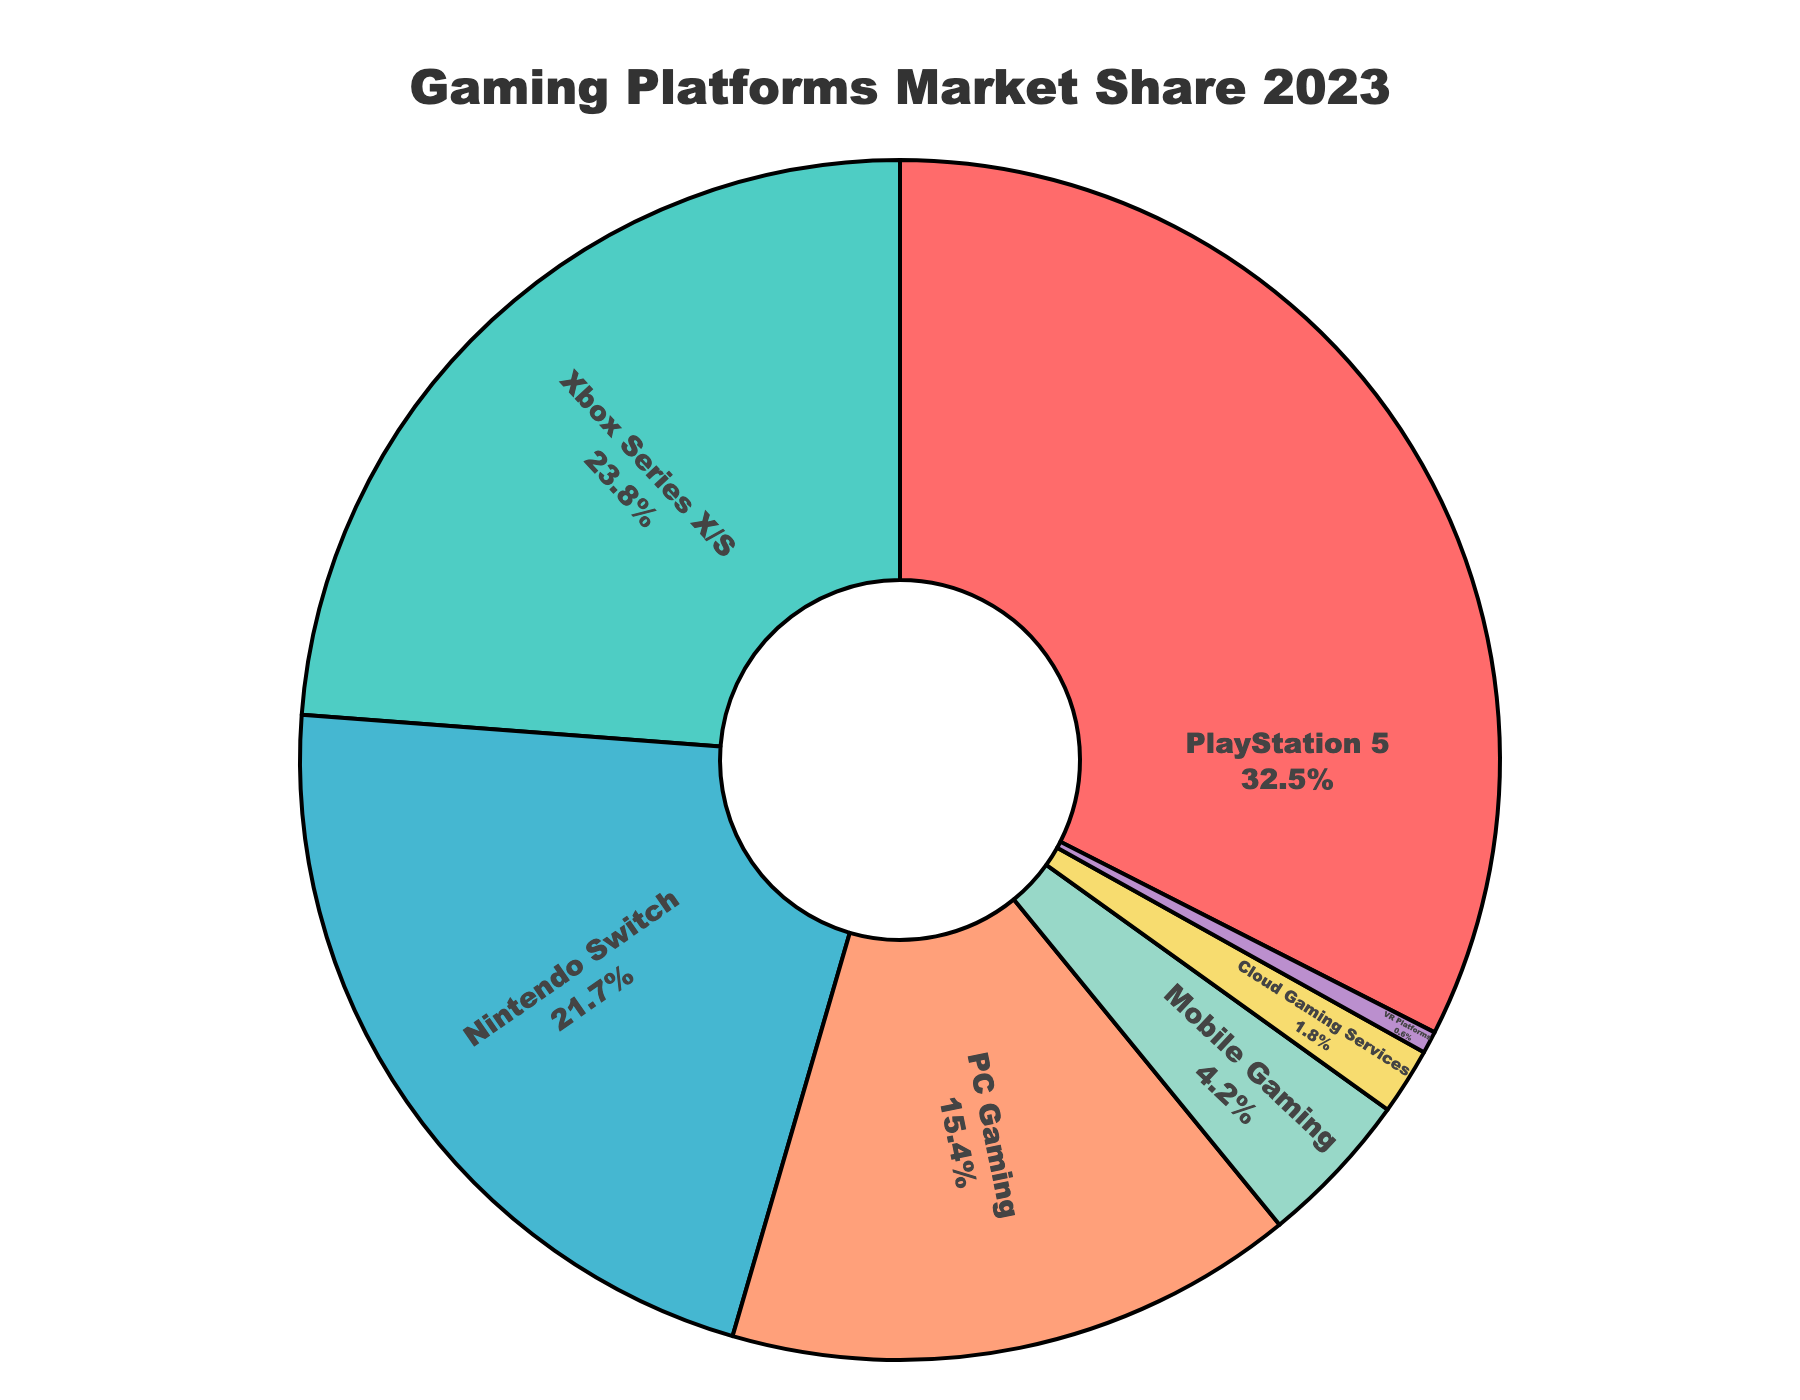What is the platform with the highest market share? The chart shows the market share percentages of various gaming platforms. The platform with the largest market share is the one with the highest value. Based on the data, PlayStation 5 has the highest market share of 32.5%.
Answer: PlayStation 5 Which platform has a smaller market share: Mobile Gaming or Cloud Gaming Services? To determine which platform has a smaller market share, compare the percentages for Mobile Gaming and Cloud Gaming Services. Mobile Gaming has a market share of 4.2%, and Cloud Gaming Services has 1.8%. Since 1.8% is less than 4.2%, Cloud Gaming Services has a smaller market share.
Answer: Cloud Gaming Services How much larger is the market share of Xbox Series X/S compared to VR Platforms? To find how much larger Xbox Series X/S's market share is compared to VR Platforms, subtract the market share of VR Platforms from that of Xbox Series X/S. Xbox Series X/S has 23.8% and VR Platforms have 0.6%. So, 23.8% - 0.6% = 23.2%.
Answer: 23.2% What is the combined market share of PC Gaming and Mobile Gaming? To find the combined market share, add the market shares of PC Gaming and Mobile Gaming. PC Gaming has 15.4% and Mobile Gaming has 4.2%. So, 15.4% + 4.2% = 19.6%.
Answer: 19.6% Between PlayStation 5 and Nintendo Switch, which has a greater market share and by how much? Compare the market shares of PlayStation 5 and Nintendo Switch. PlayStation 5 has 32.5% and Nintendo Switch has 21.7%. Subtract Nintendo Switch's share from PlayStation 5's: 32.5% - 21.7% = 10.8%.
Answer: PlayStation 5, 10.8% Which platforms have less than 10% market share? The chart shows the market share percentages of various platforms. Identify those with values less than 10%. The platforms fitting this criterion are Mobile Gaming at 4.2%, Cloud Gaming Services at 1.8%, and VR Platforms at 0.6%.
Answer: Mobile Gaming, Cloud Gaming Services, VR Platforms What percentage of the market is covered by PlayStation 5, Xbox Series X/S, and Nintendo Switch combined? To find the combined percentage of these three platforms, add their market shares together. PlayStation 5 has 32.5%, Xbox Series X/S has 23.8%, and Nintendo Switch has 21.7%. So, 32.5% + 23.8% + 21.7% = 78.0%.
Answer: 78.0% What is the difference in market share between the platform with the second highest share and the platform with the third highest share? Identify the market shares of the second and third highest platforms. Xbox Series X/S has 23.8%, and Nintendo Switch has 21.7%. Subtract the third highest (Nintendo Switch) from the second highest (Xbox Series X/S): 23.8% - 21.7% = 2.1%.
Answer: 2.1% What is the smallest market share displayed in the chart? The chart shows the market share percentages of various platforms. The smallest market share is the lowest value in the data. VR Platforms have the smallest market share at 0.6%.
Answer: 0.6% What fraction of the market does the PC Gaming platform occupy relative to the total shown in the chart? The chart shows the market share percentage for PC Gaming as 15.4%. To find the fraction, divide 15.4 by 100 (as the total market is 100%). So, 15.4 / 100 = 0.154.
Answer: 0.154 